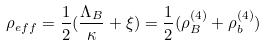<formula> <loc_0><loc_0><loc_500><loc_500>\rho _ { e f f } = \frac { 1 } { 2 } ( \frac { \Lambda _ { B } } { \kappa } + \xi ) = \frac { 1 } { 2 } ( \rho _ { B } ^ { ( 4 ) } + \rho _ { b } ^ { ( 4 ) } )</formula> 